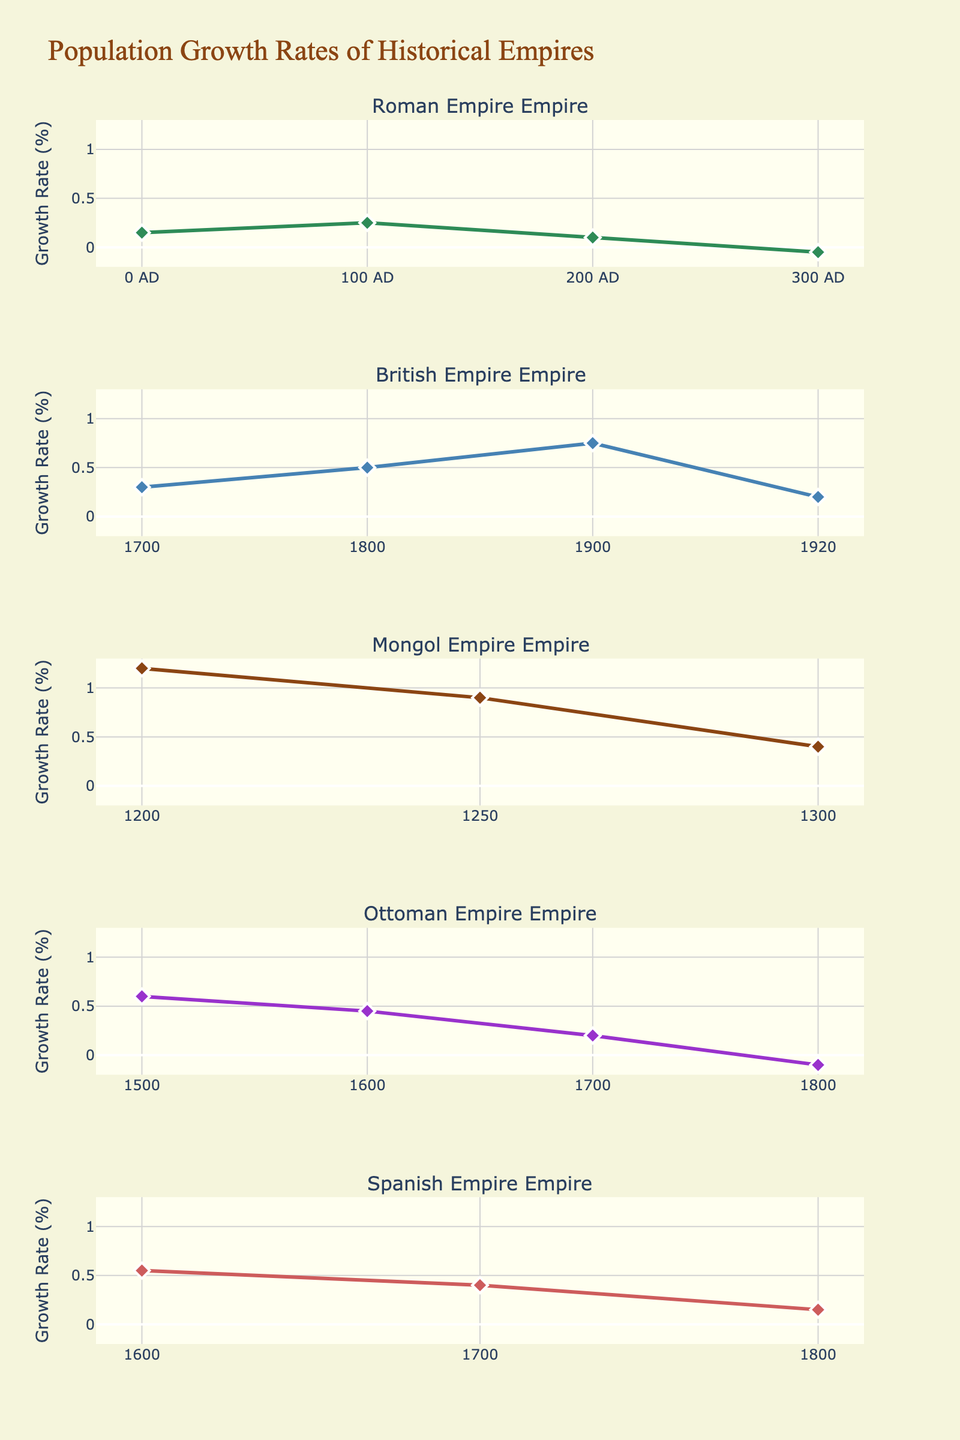What's the title of the figure? The title is located at the top of the chart and clearly states the main focus of the figure. It uses a distinct font and color to stand out.
Answer: Population Growth Rates of Historical Empires What time period shows the highest growth rate for the Mongol Empire? By examining the subplot for the Mongol Empire, the highest point on the growth rate line is observed, which corresponds to the earliest year on the x-axis.
Answer: 1200 How does the growth rate of the British Empire in 1920 compare to its growth rate in 1900? Identify the data points for the years 1900 and 1920 on the British Empire subplot, observe the growth rates, and compare them. 1900 shows a higher growth rate than 1920.
Answer: The growth rate in 1920 is lower than in 1900 Which empire has a period of negative growth rate within the timeline and during which time period does it occur? Scan through each subplot to find any section where the growth rate line dips below 0. Check the corresponding year.
Answer: The Roman Empire (300 AD) and the Ottoman Empire (1800) How many periods does the Roman Empire subplot cover? Count the unique years plotted on the x-axis of the Roman Empire subplot.
Answer: 4 periods (0 AD, 100 AD, 200 AD, 300 AD) Which empire shows the most consistently high growth rate? Observe which subplot maintains high growth rates across multiple periods without significant drops.
Answer: Mongol Empire What is the average growth rate of the British Empire across the displayed periods? Aggregate the growth rates from 1700, 1800, 1900, and 1920 and divide by the number of periods. Calculation: (0.30 + 0.50 + 0.75 + 0.20) / 4 = 0.4375
Answer: 0.44 Compare the growth rates of the Ottoman and Spanish Empires in the 1700s. Look at the specific years in the 1700s for both empires and compare their growth rates. The Ottoman Empire growth rate in 1700 is 0.20, while the Spanish Empire growth rate is 0.40.
Answer: The Spanish Empire has a higher growth rate than the Ottoman Empire in the 1700s What is the highest point reached in the growth rate by the Spanish Empire? Identify the highest peak in the Spanish Empire subplot and note the growth rate value.
Answer: 0.55 In which periods did the Roman Empire experience a decline in growth rate? Examine the Roman Empire subplot and find the periods where the line trend goes downwards.
Answer: 200 AD to 300 AD 